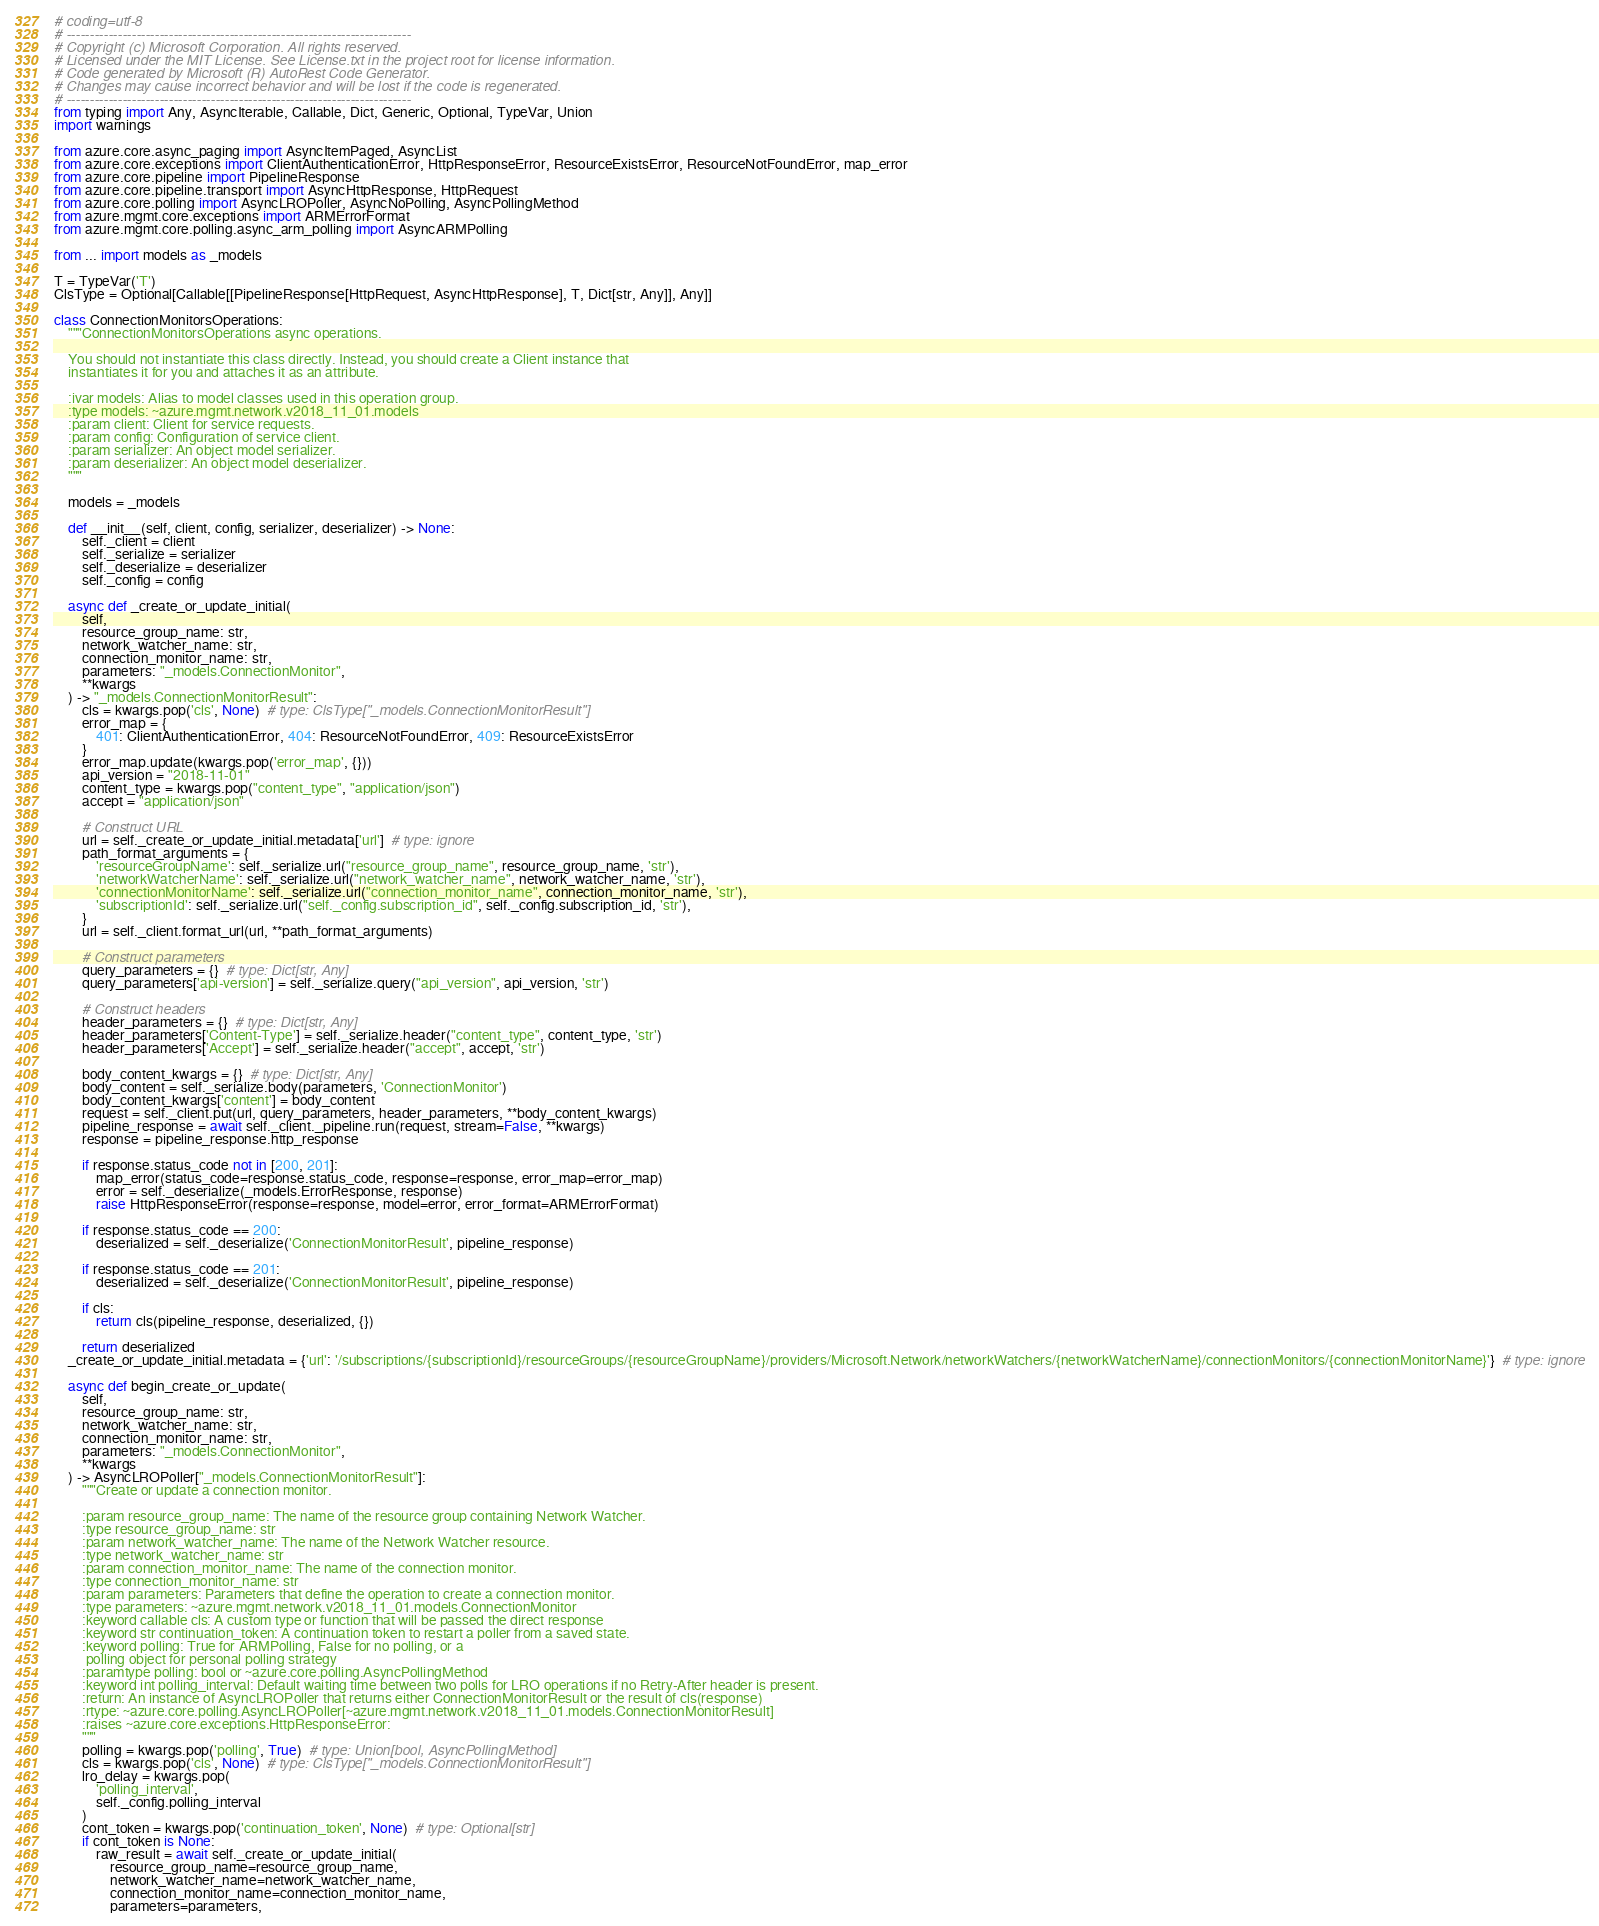<code> <loc_0><loc_0><loc_500><loc_500><_Python_># coding=utf-8
# --------------------------------------------------------------------------
# Copyright (c) Microsoft Corporation. All rights reserved.
# Licensed under the MIT License. See License.txt in the project root for license information.
# Code generated by Microsoft (R) AutoRest Code Generator.
# Changes may cause incorrect behavior and will be lost if the code is regenerated.
# --------------------------------------------------------------------------
from typing import Any, AsyncIterable, Callable, Dict, Generic, Optional, TypeVar, Union
import warnings

from azure.core.async_paging import AsyncItemPaged, AsyncList
from azure.core.exceptions import ClientAuthenticationError, HttpResponseError, ResourceExistsError, ResourceNotFoundError, map_error
from azure.core.pipeline import PipelineResponse
from azure.core.pipeline.transport import AsyncHttpResponse, HttpRequest
from azure.core.polling import AsyncLROPoller, AsyncNoPolling, AsyncPollingMethod
from azure.mgmt.core.exceptions import ARMErrorFormat
from azure.mgmt.core.polling.async_arm_polling import AsyncARMPolling

from ... import models as _models

T = TypeVar('T')
ClsType = Optional[Callable[[PipelineResponse[HttpRequest, AsyncHttpResponse], T, Dict[str, Any]], Any]]

class ConnectionMonitorsOperations:
    """ConnectionMonitorsOperations async operations.

    You should not instantiate this class directly. Instead, you should create a Client instance that
    instantiates it for you and attaches it as an attribute.

    :ivar models: Alias to model classes used in this operation group.
    :type models: ~azure.mgmt.network.v2018_11_01.models
    :param client: Client for service requests.
    :param config: Configuration of service client.
    :param serializer: An object model serializer.
    :param deserializer: An object model deserializer.
    """

    models = _models

    def __init__(self, client, config, serializer, deserializer) -> None:
        self._client = client
        self._serialize = serializer
        self._deserialize = deserializer
        self._config = config

    async def _create_or_update_initial(
        self,
        resource_group_name: str,
        network_watcher_name: str,
        connection_monitor_name: str,
        parameters: "_models.ConnectionMonitor",
        **kwargs
    ) -> "_models.ConnectionMonitorResult":
        cls = kwargs.pop('cls', None)  # type: ClsType["_models.ConnectionMonitorResult"]
        error_map = {
            401: ClientAuthenticationError, 404: ResourceNotFoundError, 409: ResourceExistsError
        }
        error_map.update(kwargs.pop('error_map', {}))
        api_version = "2018-11-01"
        content_type = kwargs.pop("content_type", "application/json")
        accept = "application/json"

        # Construct URL
        url = self._create_or_update_initial.metadata['url']  # type: ignore
        path_format_arguments = {
            'resourceGroupName': self._serialize.url("resource_group_name", resource_group_name, 'str'),
            'networkWatcherName': self._serialize.url("network_watcher_name", network_watcher_name, 'str'),
            'connectionMonitorName': self._serialize.url("connection_monitor_name", connection_monitor_name, 'str'),
            'subscriptionId': self._serialize.url("self._config.subscription_id", self._config.subscription_id, 'str'),
        }
        url = self._client.format_url(url, **path_format_arguments)

        # Construct parameters
        query_parameters = {}  # type: Dict[str, Any]
        query_parameters['api-version'] = self._serialize.query("api_version", api_version, 'str')

        # Construct headers
        header_parameters = {}  # type: Dict[str, Any]
        header_parameters['Content-Type'] = self._serialize.header("content_type", content_type, 'str')
        header_parameters['Accept'] = self._serialize.header("accept", accept, 'str')

        body_content_kwargs = {}  # type: Dict[str, Any]
        body_content = self._serialize.body(parameters, 'ConnectionMonitor')
        body_content_kwargs['content'] = body_content
        request = self._client.put(url, query_parameters, header_parameters, **body_content_kwargs)
        pipeline_response = await self._client._pipeline.run(request, stream=False, **kwargs)
        response = pipeline_response.http_response

        if response.status_code not in [200, 201]:
            map_error(status_code=response.status_code, response=response, error_map=error_map)
            error = self._deserialize(_models.ErrorResponse, response)
            raise HttpResponseError(response=response, model=error, error_format=ARMErrorFormat)

        if response.status_code == 200:
            deserialized = self._deserialize('ConnectionMonitorResult', pipeline_response)

        if response.status_code == 201:
            deserialized = self._deserialize('ConnectionMonitorResult', pipeline_response)

        if cls:
            return cls(pipeline_response, deserialized, {})

        return deserialized
    _create_or_update_initial.metadata = {'url': '/subscriptions/{subscriptionId}/resourceGroups/{resourceGroupName}/providers/Microsoft.Network/networkWatchers/{networkWatcherName}/connectionMonitors/{connectionMonitorName}'}  # type: ignore

    async def begin_create_or_update(
        self,
        resource_group_name: str,
        network_watcher_name: str,
        connection_monitor_name: str,
        parameters: "_models.ConnectionMonitor",
        **kwargs
    ) -> AsyncLROPoller["_models.ConnectionMonitorResult"]:
        """Create or update a connection monitor.

        :param resource_group_name: The name of the resource group containing Network Watcher.
        :type resource_group_name: str
        :param network_watcher_name: The name of the Network Watcher resource.
        :type network_watcher_name: str
        :param connection_monitor_name: The name of the connection monitor.
        :type connection_monitor_name: str
        :param parameters: Parameters that define the operation to create a connection monitor.
        :type parameters: ~azure.mgmt.network.v2018_11_01.models.ConnectionMonitor
        :keyword callable cls: A custom type or function that will be passed the direct response
        :keyword str continuation_token: A continuation token to restart a poller from a saved state.
        :keyword polling: True for ARMPolling, False for no polling, or a
         polling object for personal polling strategy
        :paramtype polling: bool or ~azure.core.polling.AsyncPollingMethod
        :keyword int polling_interval: Default waiting time between two polls for LRO operations if no Retry-After header is present.
        :return: An instance of AsyncLROPoller that returns either ConnectionMonitorResult or the result of cls(response)
        :rtype: ~azure.core.polling.AsyncLROPoller[~azure.mgmt.network.v2018_11_01.models.ConnectionMonitorResult]
        :raises ~azure.core.exceptions.HttpResponseError:
        """
        polling = kwargs.pop('polling', True)  # type: Union[bool, AsyncPollingMethod]
        cls = kwargs.pop('cls', None)  # type: ClsType["_models.ConnectionMonitorResult"]
        lro_delay = kwargs.pop(
            'polling_interval',
            self._config.polling_interval
        )
        cont_token = kwargs.pop('continuation_token', None)  # type: Optional[str]
        if cont_token is None:
            raw_result = await self._create_or_update_initial(
                resource_group_name=resource_group_name,
                network_watcher_name=network_watcher_name,
                connection_monitor_name=connection_monitor_name,
                parameters=parameters,</code> 